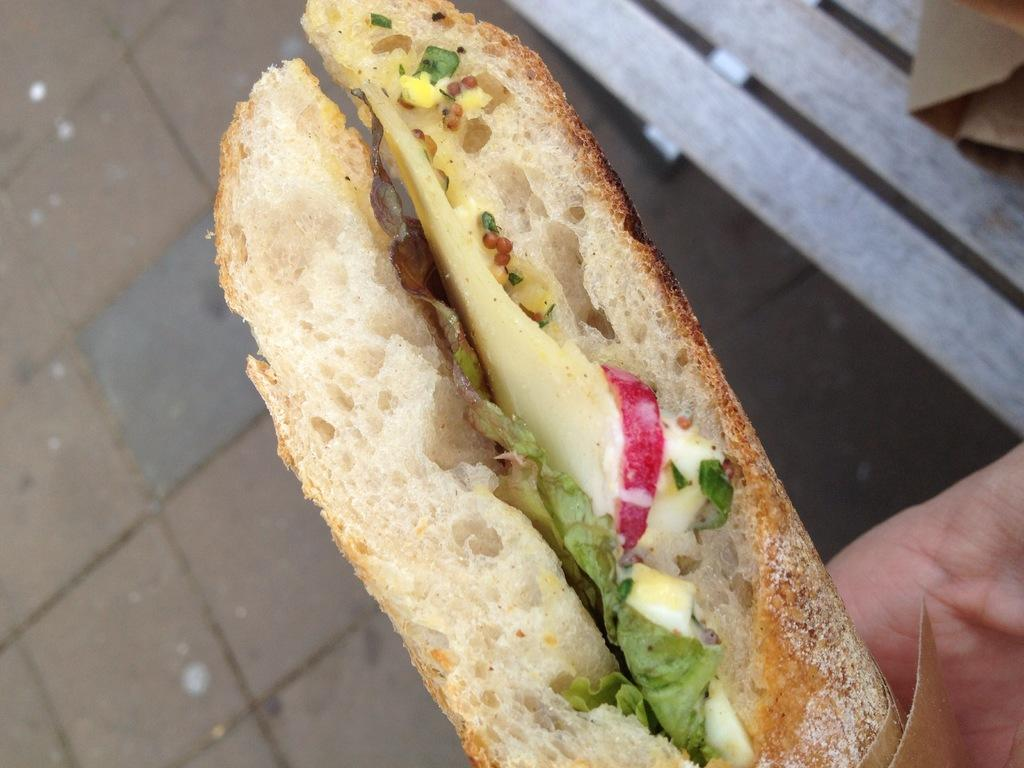What is the person in the image holding? The person is holding a food item in the image. What can be seen behind the person? There is a floor visible in the background of the image. What object is on the right side of the image? There is a bench on the right side of the image. What theory is being discussed in the library in the image? There is no library present in the image, and no discussion or theory can be observed. 